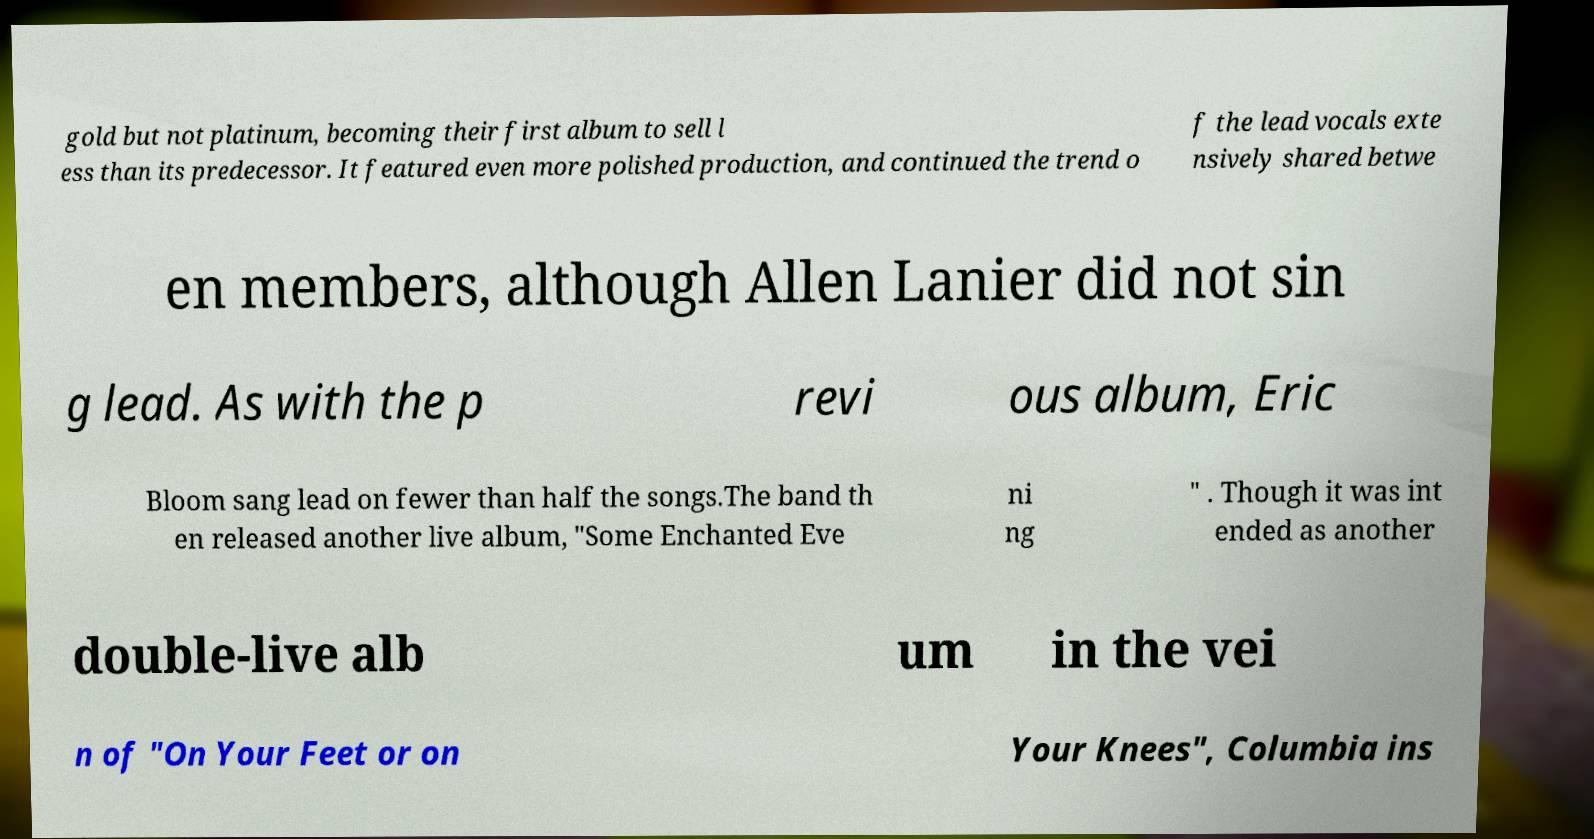Can you read and provide the text displayed in the image?This photo seems to have some interesting text. Can you extract and type it out for me? gold but not platinum, becoming their first album to sell l ess than its predecessor. It featured even more polished production, and continued the trend o f the lead vocals exte nsively shared betwe en members, although Allen Lanier did not sin g lead. As with the p revi ous album, Eric Bloom sang lead on fewer than half the songs.The band th en released another live album, "Some Enchanted Eve ni ng " . Though it was int ended as another double-live alb um in the vei n of "On Your Feet or on Your Knees", Columbia ins 